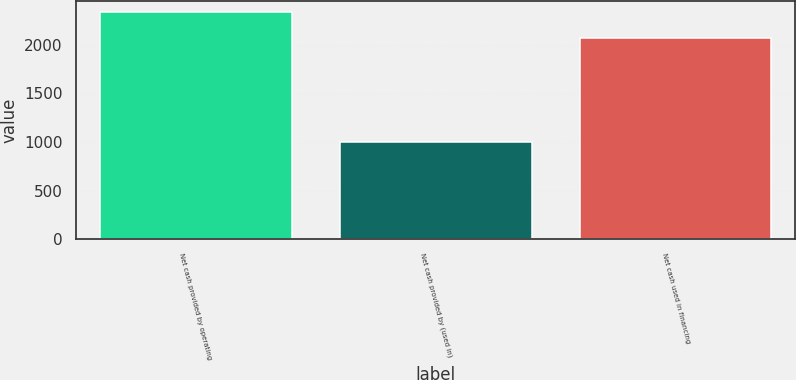Convert chart to OTSL. <chart><loc_0><loc_0><loc_500><loc_500><bar_chart><fcel>Net cash provided by operating<fcel>Net cash provided by (used in)<fcel>Net cash used in financing<nl><fcel>2331<fcel>995<fcel>2072<nl></chart> 